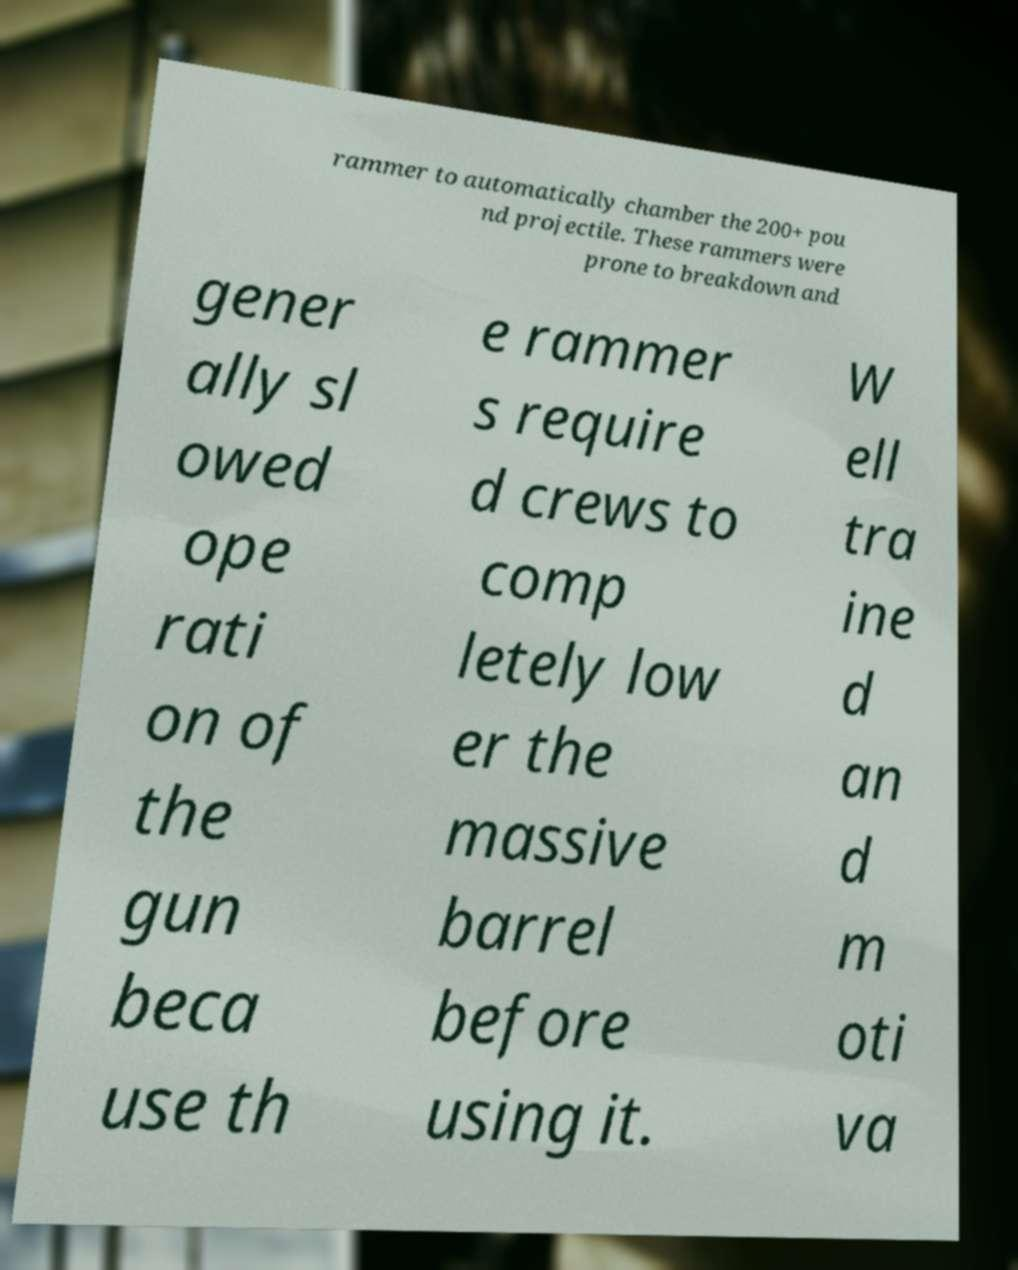What messages or text are displayed in this image? I need them in a readable, typed format. rammer to automatically chamber the 200+ pou nd projectile. These rammers were prone to breakdown and gener ally sl owed ope rati on of the gun beca use th e rammer s require d crews to comp letely low er the massive barrel before using it. W ell tra ine d an d m oti va 